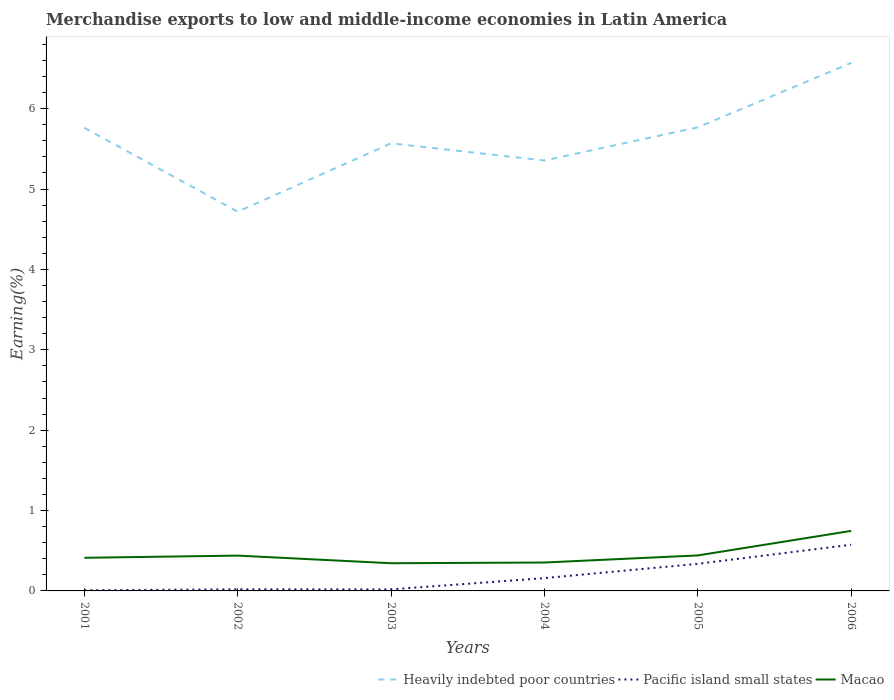Does the line corresponding to Pacific island small states intersect with the line corresponding to Macao?
Your response must be concise. No. Is the number of lines equal to the number of legend labels?
Give a very brief answer. Yes. Across all years, what is the maximum percentage of amount earned from merchandise exports in Pacific island small states?
Provide a short and direct response. 0.01. What is the total percentage of amount earned from merchandise exports in Pacific island small states in the graph?
Give a very brief answer. 0. What is the difference between the highest and the second highest percentage of amount earned from merchandise exports in Macao?
Offer a very short reply. 0.4. How many lines are there?
Provide a short and direct response. 3. What is the difference between two consecutive major ticks on the Y-axis?
Offer a very short reply. 1. Does the graph contain grids?
Offer a terse response. No. Where does the legend appear in the graph?
Ensure brevity in your answer.  Bottom right. How many legend labels are there?
Provide a short and direct response. 3. What is the title of the graph?
Give a very brief answer. Merchandise exports to low and middle-income economies in Latin America. What is the label or title of the X-axis?
Give a very brief answer. Years. What is the label or title of the Y-axis?
Ensure brevity in your answer.  Earning(%). What is the Earning(%) in Heavily indebted poor countries in 2001?
Your answer should be compact. 5.76. What is the Earning(%) of Pacific island small states in 2001?
Make the answer very short. 0.01. What is the Earning(%) of Macao in 2001?
Your response must be concise. 0.41. What is the Earning(%) of Heavily indebted poor countries in 2002?
Ensure brevity in your answer.  4.72. What is the Earning(%) in Pacific island small states in 2002?
Offer a terse response. 0.02. What is the Earning(%) in Macao in 2002?
Provide a short and direct response. 0.44. What is the Earning(%) in Heavily indebted poor countries in 2003?
Offer a very short reply. 5.57. What is the Earning(%) of Pacific island small states in 2003?
Keep it short and to the point. 0.02. What is the Earning(%) of Macao in 2003?
Offer a terse response. 0.34. What is the Earning(%) in Heavily indebted poor countries in 2004?
Keep it short and to the point. 5.36. What is the Earning(%) in Pacific island small states in 2004?
Offer a very short reply. 0.16. What is the Earning(%) of Macao in 2004?
Your answer should be compact. 0.35. What is the Earning(%) of Heavily indebted poor countries in 2005?
Provide a short and direct response. 5.77. What is the Earning(%) in Pacific island small states in 2005?
Offer a terse response. 0.34. What is the Earning(%) of Macao in 2005?
Your answer should be compact. 0.44. What is the Earning(%) in Heavily indebted poor countries in 2006?
Keep it short and to the point. 6.57. What is the Earning(%) of Pacific island small states in 2006?
Provide a short and direct response. 0.57. What is the Earning(%) of Macao in 2006?
Your response must be concise. 0.75. Across all years, what is the maximum Earning(%) of Heavily indebted poor countries?
Make the answer very short. 6.57. Across all years, what is the maximum Earning(%) of Pacific island small states?
Your response must be concise. 0.57. Across all years, what is the maximum Earning(%) in Macao?
Your answer should be compact. 0.75. Across all years, what is the minimum Earning(%) of Heavily indebted poor countries?
Offer a very short reply. 4.72. Across all years, what is the minimum Earning(%) of Pacific island small states?
Your answer should be compact. 0.01. Across all years, what is the minimum Earning(%) of Macao?
Your answer should be very brief. 0.34. What is the total Earning(%) of Heavily indebted poor countries in the graph?
Keep it short and to the point. 33.74. What is the total Earning(%) of Pacific island small states in the graph?
Provide a short and direct response. 1.12. What is the total Earning(%) in Macao in the graph?
Provide a succinct answer. 2.74. What is the difference between the Earning(%) in Heavily indebted poor countries in 2001 and that in 2002?
Make the answer very short. 1.04. What is the difference between the Earning(%) in Pacific island small states in 2001 and that in 2002?
Your answer should be compact. -0.01. What is the difference between the Earning(%) of Macao in 2001 and that in 2002?
Your answer should be compact. -0.03. What is the difference between the Earning(%) of Heavily indebted poor countries in 2001 and that in 2003?
Make the answer very short. 0.19. What is the difference between the Earning(%) in Pacific island small states in 2001 and that in 2003?
Offer a very short reply. -0.01. What is the difference between the Earning(%) of Macao in 2001 and that in 2003?
Provide a succinct answer. 0.07. What is the difference between the Earning(%) in Heavily indebted poor countries in 2001 and that in 2004?
Provide a short and direct response. 0.41. What is the difference between the Earning(%) in Pacific island small states in 2001 and that in 2004?
Provide a succinct answer. -0.15. What is the difference between the Earning(%) of Macao in 2001 and that in 2004?
Provide a succinct answer. 0.06. What is the difference between the Earning(%) of Heavily indebted poor countries in 2001 and that in 2005?
Give a very brief answer. -0.01. What is the difference between the Earning(%) of Pacific island small states in 2001 and that in 2005?
Give a very brief answer. -0.33. What is the difference between the Earning(%) in Macao in 2001 and that in 2005?
Provide a succinct answer. -0.03. What is the difference between the Earning(%) of Heavily indebted poor countries in 2001 and that in 2006?
Make the answer very short. -0.81. What is the difference between the Earning(%) of Pacific island small states in 2001 and that in 2006?
Offer a very short reply. -0.57. What is the difference between the Earning(%) in Macao in 2001 and that in 2006?
Your response must be concise. -0.33. What is the difference between the Earning(%) in Heavily indebted poor countries in 2002 and that in 2003?
Provide a short and direct response. -0.85. What is the difference between the Earning(%) of Macao in 2002 and that in 2003?
Give a very brief answer. 0.09. What is the difference between the Earning(%) in Heavily indebted poor countries in 2002 and that in 2004?
Make the answer very short. -0.64. What is the difference between the Earning(%) of Pacific island small states in 2002 and that in 2004?
Your response must be concise. -0.14. What is the difference between the Earning(%) in Macao in 2002 and that in 2004?
Offer a terse response. 0.09. What is the difference between the Earning(%) in Heavily indebted poor countries in 2002 and that in 2005?
Keep it short and to the point. -1.05. What is the difference between the Earning(%) in Pacific island small states in 2002 and that in 2005?
Provide a short and direct response. -0.32. What is the difference between the Earning(%) of Macao in 2002 and that in 2005?
Make the answer very short. -0. What is the difference between the Earning(%) in Heavily indebted poor countries in 2002 and that in 2006?
Ensure brevity in your answer.  -1.85. What is the difference between the Earning(%) in Pacific island small states in 2002 and that in 2006?
Your answer should be very brief. -0.55. What is the difference between the Earning(%) of Macao in 2002 and that in 2006?
Offer a terse response. -0.31. What is the difference between the Earning(%) in Heavily indebted poor countries in 2003 and that in 2004?
Your answer should be very brief. 0.21. What is the difference between the Earning(%) in Pacific island small states in 2003 and that in 2004?
Your response must be concise. -0.14. What is the difference between the Earning(%) in Macao in 2003 and that in 2004?
Keep it short and to the point. -0.01. What is the difference between the Earning(%) of Heavily indebted poor countries in 2003 and that in 2005?
Your response must be concise. -0.2. What is the difference between the Earning(%) in Pacific island small states in 2003 and that in 2005?
Provide a short and direct response. -0.32. What is the difference between the Earning(%) of Macao in 2003 and that in 2005?
Your response must be concise. -0.1. What is the difference between the Earning(%) in Heavily indebted poor countries in 2003 and that in 2006?
Offer a very short reply. -1. What is the difference between the Earning(%) of Pacific island small states in 2003 and that in 2006?
Offer a terse response. -0.56. What is the difference between the Earning(%) in Macao in 2003 and that in 2006?
Offer a terse response. -0.4. What is the difference between the Earning(%) of Heavily indebted poor countries in 2004 and that in 2005?
Give a very brief answer. -0.41. What is the difference between the Earning(%) of Pacific island small states in 2004 and that in 2005?
Offer a terse response. -0.18. What is the difference between the Earning(%) in Macao in 2004 and that in 2005?
Provide a short and direct response. -0.09. What is the difference between the Earning(%) in Heavily indebted poor countries in 2004 and that in 2006?
Keep it short and to the point. -1.21. What is the difference between the Earning(%) in Pacific island small states in 2004 and that in 2006?
Offer a very short reply. -0.42. What is the difference between the Earning(%) of Macao in 2004 and that in 2006?
Give a very brief answer. -0.39. What is the difference between the Earning(%) of Heavily indebted poor countries in 2005 and that in 2006?
Offer a terse response. -0.8. What is the difference between the Earning(%) in Pacific island small states in 2005 and that in 2006?
Your response must be concise. -0.24. What is the difference between the Earning(%) of Macao in 2005 and that in 2006?
Offer a terse response. -0.31. What is the difference between the Earning(%) of Heavily indebted poor countries in 2001 and the Earning(%) of Pacific island small states in 2002?
Your response must be concise. 5.74. What is the difference between the Earning(%) in Heavily indebted poor countries in 2001 and the Earning(%) in Macao in 2002?
Offer a terse response. 5.32. What is the difference between the Earning(%) of Pacific island small states in 2001 and the Earning(%) of Macao in 2002?
Provide a short and direct response. -0.43. What is the difference between the Earning(%) in Heavily indebted poor countries in 2001 and the Earning(%) in Pacific island small states in 2003?
Give a very brief answer. 5.74. What is the difference between the Earning(%) of Heavily indebted poor countries in 2001 and the Earning(%) of Macao in 2003?
Offer a very short reply. 5.42. What is the difference between the Earning(%) in Pacific island small states in 2001 and the Earning(%) in Macao in 2003?
Provide a short and direct response. -0.34. What is the difference between the Earning(%) in Heavily indebted poor countries in 2001 and the Earning(%) in Pacific island small states in 2004?
Offer a terse response. 5.6. What is the difference between the Earning(%) in Heavily indebted poor countries in 2001 and the Earning(%) in Macao in 2004?
Your answer should be compact. 5.41. What is the difference between the Earning(%) of Pacific island small states in 2001 and the Earning(%) of Macao in 2004?
Offer a terse response. -0.35. What is the difference between the Earning(%) of Heavily indebted poor countries in 2001 and the Earning(%) of Pacific island small states in 2005?
Provide a short and direct response. 5.42. What is the difference between the Earning(%) of Heavily indebted poor countries in 2001 and the Earning(%) of Macao in 2005?
Give a very brief answer. 5.32. What is the difference between the Earning(%) of Pacific island small states in 2001 and the Earning(%) of Macao in 2005?
Provide a succinct answer. -0.43. What is the difference between the Earning(%) in Heavily indebted poor countries in 2001 and the Earning(%) in Pacific island small states in 2006?
Your answer should be compact. 5.19. What is the difference between the Earning(%) in Heavily indebted poor countries in 2001 and the Earning(%) in Macao in 2006?
Offer a very short reply. 5.01. What is the difference between the Earning(%) of Pacific island small states in 2001 and the Earning(%) of Macao in 2006?
Provide a short and direct response. -0.74. What is the difference between the Earning(%) of Heavily indebted poor countries in 2002 and the Earning(%) of Pacific island small states in 2003?
Give a very brief answer. 4.7. What is the difference between the Earning(%) of Heavily indebted poor countries in 2002 and the Earning(%) of Macao in 2003?
Provide a short and direct response. 4.37. What is the difference between the Earning(%) in Pacific island small states in 2002 and the Earning(%) in Macao in 2003?
Your response must be concise. -0.32. What is the difference between the Earning(%) of Heavily indebted poor countries in 2002 and the Earning(%) of Pacific island small states in 2004?
Provide a short and direct response. 4.56. What is the difference between the Earning(%) in Heavily indebted poor countries in 2002 and the Earning(%) in Macao in 2004?
Provide a succinct answer. 4.36. What is the difference between the Earning(%) of Pacific island small states in 2002 and the Earning(%) of Macao in 2004?
Your response must be concise. -0.33. What is the difference between the Earning(%) in Heavily indebted poor countries in 2002 and the Earning(%) in Pacific island small states in 2005?
Your answer should be compact. 4.38. What is the difference between the Earning(%) of Heavily indebted poor countries in 2002 and the Earning(%) of Macao in 2005?
Make the answer very short. 4.28. What is the difference between the Earning(%) of Pacific island small states in 2002 and the Earning(%) of Macao in 2005?
Provide a succinct answer. -0.42. What is the difference between the Earning(%) in Heavily indebted poor countries in 2002 and the Earning(%) in Pacific island small states in 2006?
Your answer should be very brief. 4.14. What is the difference between the Earning(%) of Heavily indebted poor countries in 2002 and the Earning(%) of Macao in 2006?
Give a very brief answer. 3.97. What is the difference between the Earning(%) in Pacific island small states in 2002 and the Earning(%) in Macao in 2006?
Offer a very short reply. -0.73. What is the difference between the Earning(%) of Heavily indebted poor countries in 2003 and the Earning(%) of Pacific island small states in 2004?
Your answer should be very brief. 5.41. What is the difference between the Earning(%) of Heavily indebted poor countries in 2003 and the Earning(%) of Macao in 2004?
Offer a terse response. 5.21. What is the difference between the Earning(%) in Pacific island small states in 2003 and the Earning(%) in Macao in 2004?
Ensure brevity in your answer.  -0.33. What is the difference between the Earning(%) in Heavily indebted poor countries in 2003 and the Earning(%) in Pacific island small states in 2005?
Ensure brevity in your answer.  5.23. What is the difference between the Earning(%) in Heavily indebted poor countries in 2003 and the Earning(%) in Macao in 2005?
Provide a succinct answer. 5.13. What is the difference between the Earning(%) in Pacific island small states in 2003 and the Earning(%) in Macao in 2005?
Your answer should be compact. -0.42. What is the difference between the Earning(%) of Heavily indebted poor countries in 2003 and the Earning(%) of Pacific island small states in 2006?
Your response must be concise. 4.99. What is the difference between the Earning(%) of Heavily indebted poor countries in 2003 and the Earning(%) of Macao in 2006?
Offer a very short reply. 4.82. What is the difference between the Earning(%) in Pacific island small states in 2003 and the Earning(%) in Macao in 2006?
Ensure brevity in your answer.  -0.73. What is the difference between the Earning(%) in Heavily indebted poor countries in 2004 and the Earning(%) in Pacific island small states in 2005?
Make the answer very short. 5.02. What is the difference between the Earning(%) of Heavily indebted poor countries in 2004 and the Earning(%) of Macao in 2005?
Provide a succinct answer. 4.91. What is the difference between the Earning(%) in Pacific island small states in 2004 and the Earning(%) in Macao in 2005?
Provide a succinct answer. -0.28. What is the difference between the Earning(%) of Heavily indebted poor countries in 2004 and the Earning(%) of Pacific island small states in 2006?
Make the answer very short. 4.78. What is the difference between the Earning(%) in Heavily indebted poor countries in 2004 and the Earning(%) in Macao in 2006?
Make the answer very short. 4.61. What is the difference between the Earning(%) in Pacific island small states in 2004 and the Earning(%) in Macao in 2006?
Make the answer very short. -0.59. What is the difference between the Earning(%) in Heavily indebted poor countries in 2005 and the Earning(%) in Pacific island small states in 2006?
Provide a short and direct response. 5.19. What is the difference between the Earning(%) of Heavily indebted poor countries in 2005 and the Earning(%) of Macao in 2006?
Your answer should be compact. 5.02. What is the difference between the Earning(%) in Pacific island small states in 2005 and the Earning(%) in Macao in 2006?
Your answer should be very brief. -0.41. What is the average Earning(%) of Heavily indebted poor countries per year?
Ensure brevity in your answer.  5.62. What is the average Earning(%) of Pacific island small states per year?
Give a very brief answer. 0.19. What is the average Earning(%) in Macao per year?
Ensure brevity in your answer.  0.46. In the year 2001, what is the difference between the Earning(%) of Heavily indebted poor countries and Earning(%) of Pacific island small states?
Offer a very short reply. 5.75. In the year 2001, what is the difference between the Earning(%) in Heavily indebted poor countries and Earning(%) in Macao?
Your response must be concise. 5.35. In the year 2001, what is the difference between the Earning(%) in Pacific island small states and Earning(%) in Macao?
Keep it short and to the point. -0.4. In the year 2002, what is the difference between the Earning(%) in Heavily indebted poor countries and Earning(%) in Pacific island small states?
Make the answer very short. 4.7. In the year 2002, what is the difference between the Earning(%) in Heavily indebted poor countries and Earning(%) in Macao?
Ensure brevity in your answer.  4.28. In the year 2002, what is the difference between the Earning(%) in Pacific island small states and Earning(%) in Macao?
Your answer should be very brief. -0.42. In the year 2003, what is the difference between the Earning(%) in Heavily indebted poor countries and Earning(%) in Pacific island small states?
Offer a very short reply. 5.55. In the year 2003, what is the difference between the Earning(%) in Heavily indebted poor countries and Earning(%) in Macao?
Give a very brief answer. 5.22. In the year 2003, what is the difference between the Earning(%) in Pacific island small states and Earning(%) in Macao?
Keep it short and to the point. -0.33. In the year 2004, what is the difference between the Earning(%) of Heavily indebted poor countries and Earning(%) of Pacific island small states?
Give a very brief answer. 5.2. In the year 2004, what is the difference between the Earning(%) in Heavily indebted poor countries and Earning(%) in Macao?
Keep it short and to the point. 5. In the year 2004, what is the difference between the Earning(%) of Pacific island small states and Earning(%) of Macao?
Your answer should be very brief. -0.19. In the year 2005, what is the difference between the Earning(%) of Heavily indebted poor countries and Earning(%) of Pacific island small states?
Give a very brief answer. 5.43. In the year 2005, what is the difference between the Earning(%) in Heavily indebted poor countries and Earning(%) in Macao?
Make the answer very short. 5.33. In the year 2005, what is the difference between the Earning(%) of Pacific island small states and Earning(%) of Macao?
Your answer should be compact. -0.1. In the year 2006, what is the difference between the Earning(%) of Heavily indebted poor countries and Earning(%) of Pacific island small states?
Keep it short and to the point. 5.99. In the year 2006, what is the difference between the Earning(%) of Heavily indebted poor countries and Earning(%) of Macao?
Give a very brief answer. 5.82. In the year 2006, what is the difference between the Earning(%) in Pacific island small states and Earning(%) in Macao?
Provide a short and direct response. -0.17. What is the ratio of the Earning(%) of Heavily indebted poor countries in 2001 to that in 2002?
Make the answer very short. 1.22. What is the ratio of the Earning(%) of Pacific island small states in 2001 to that in 2002?
Give a very brief answer. 0.41. What is the ratio of the Earning(%) of Macao in 2001 to that in 2002?
Make the answer very short. 0.94. What is the ratio of the Earning(%) in Heavily indebted poor countries in 2001 to that in 2003?
Keep it short and to the point. 1.03. What is the ratio of the Earning(%) of Pacific island small states in 2001 to that in 2003?
Offer a very short reply. 0.43. What is the ratio of the Earning(%) in Macao in 2001 to that in 2003?
Your answer should be compact. 1.2. What is the ratio of the Earning(%) in Heavily indebted poor countries in 2001 to that in 2004?
Give a very brief answer. 1.08. What is the ratio of the Earning(%) of Pacific island small states in 2001 to that in 2004?
Make the answer very short. 0.05. What is the ratio of the Earning(%) of Macao in 2001 to that in 2004?
Provide a short and direct response. 1.17. What is the ratio of the Earning(%) of Heavily indebted poor countries in 2001 to that in 2005?
Offer a terse response. 1. What is the ratio of the Earning(%) of Pacific island small states in 2001 to that in 2005?
Your response must be concise. 0.02. What is the ratio of the Earning(%) in Macao in 2001 to that in 2005?
Keep it short and to the point. 0.93. What is the ratio of the Earning(%) in Heavily indebted poor countries in 2001 to that in 2006?
Your response must be concise. 0.88. What is the ratio of the Earning(%) in Pacific island small states in 2001 to that in 2006?
Your answer should be compact. 0.01. What is the ratio of the Earning(%) of Macao in 2001 to that in 2006?
Your answer should be compact. 0.55. What is the ratio of the Earning(%) in Heavily indebted poor countries in 2002 to that in 2003?
Provide a succinct answer. 0.85. What is the ratio of the Earning(%) in Pacific island small states in 2002 to that in 2003?
Your answer should be compact. 1.05. What is the ratio of the Earning(%) in Macao in 2002 to that in 2003?
Your answer should be very brief. 1.27. What is the ratio of the Earning(%) in Heavily indebted poor countries in 2002 to that in 2004?
Your answer should be compact. 0.88. What is the ratio of the Earning(%) in Pacific island small states in 2002 to that in 2004?
Keep it short and to the point. 0.13. What is the ratio of the Earning(%) of Macao in 2002 to that in 2004?
Offer a very short reply. 1.24. What is the ratio of the Earning(%) of Heavily indebted poor countries in 2002 to that in 2005?
Ensure brevity in your answer.  0.82. What is the ratio of the Earning(%) of Pacific island small states in 2002 to that in 2005?
Offer a terse response. 0.06. What is the ratio of the Earning(%) of Macao in 2002 to that in 2005?
Offer a terse response. 0.99. What is the ratio of the Earning(%) of Heavily indebted poor countries in 2002 to that in 2006?
Provide a succinct answer. 0.72. What is the ratio of the Earning(%) in Pacific island small states in 2002 to that in 2006?
Give a very brief answer. 0.04. What is the ratio of the Earning(%) of Macao in 2002 to that in 2006?
Make the answer very short. 0.59. What is the ratio of the Earning(%) in Heavily indebted poor countries in 2003 to that in 2004?
Give a very brief answer. 1.04. What is the ratio of the Earning(%) in Pacific island small states in 2003 to that in 2004?
Your answer should be very brief. 0.12. What is the ratio of the Earning(%) in Macao in 2003 to that in 2004?
Keep it short and to the point. 0.97. What is the ratio of the Earning(%) of Heavily indebted poor countries in 2003 to that in 2005?
Make the answer very short. 0.97. What is the ratio of the Earning(%) in Pacific island small states in 2003 to that in 2005?
Provide a succinct answer. 0.06. What is the ratio of the Earning(%) of Macao in 2003 to that in 2005?
Offer a terse response. 0.78. What is the ratio of the Earning(%) in Heavily indebted poor countries in 2003 to that in 2006?
Keep it short and to the point. 0.85. What is the ratio of the Earning(%) in Pacific island small states in 2003 to that in 2006?
Ensure brevity in your answer.  0.03. What is the ratio of the Earning(%) of Macao in 2003 to that in 2006?
Your answer should be very brief. 0.46. What is the ratio of the Earning(%) of Heavily indebted poor countries in 2004 to that in 2005?
Give a very brief answer. 0.93. What is the ratio of the Earning(%) of Pacific island small states in 2004 to that in 2005?
Your answer should be compact. 0.47. What is the ratio of the Earning(%) of Macao in 2004 to that in 2005?
Your answer should be very brief. 0.8. What is the ratio of the Earning(%) of Heavily indebted poor countries in 2004 to that in 2006?
Ensure brevity in your answer.  0.82. What is the ratio of the Earning(%) of Pacific island small states in 2004 to that in 2006?
Offer a very short reply. 0.28. What is the ratio of the Earning(%) in Macao in 2004 to that in 2006?
Give a very brief answer. 0.47. What is the ratio of the Earning(%) of Heavily indebted poor countries in 2005 to that in 2006?
Provide a short and direct response. 0.88. What is the ratio of the Earning(%) in Pacific island small states in 2005 to that in 2006?
Your answer should be compact. 0.59. What is the ratio of the Earning(%) in Macao in 2005 to that in 2006?
Give a very brief answer. 0.59. What is the difference between the highest and the second highest Earning(%) in Heavily indebted poor countries?
Your answer should be very brief. 0.8. What is the difference between the highest and the second highest Earning(%) of Pacific island small states?
Keep it short and to the point. 0.24. What is the difference between the highest and the second highest Earning(%) in Macao?
Give a very brief answer. 0.31. What is the difference between the highest and the lowest Earning(%) of Heavily indebted poor countries?
Keep it short and to the point. 1.85. What is the difference between the highest and the lowest Earning(%) of Pacific island small states?
Your answer should be compact. 0.57. What is the difference between the highest and the lowest Earning(%) in Macao?
Your answer should be compact. 0.4. 